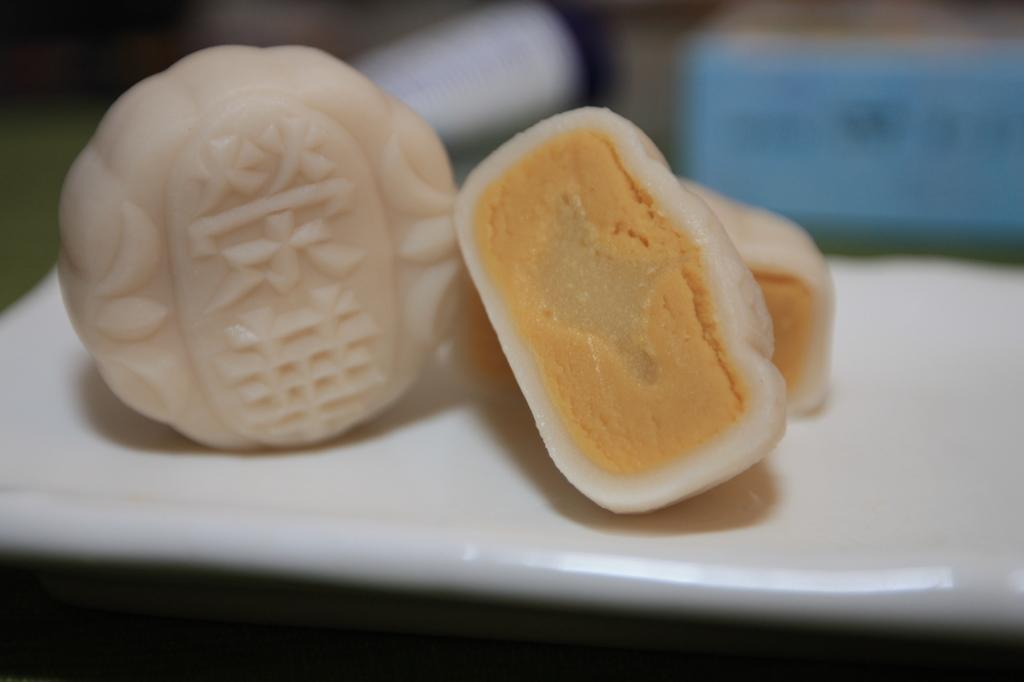How would you summarize this image in a sentence or two? In this picture, we see the eatables are placed in the white plate. At the bottom, it is black in color. In the background, we see some objects in white and blue color. This picture is blurred in the background. 